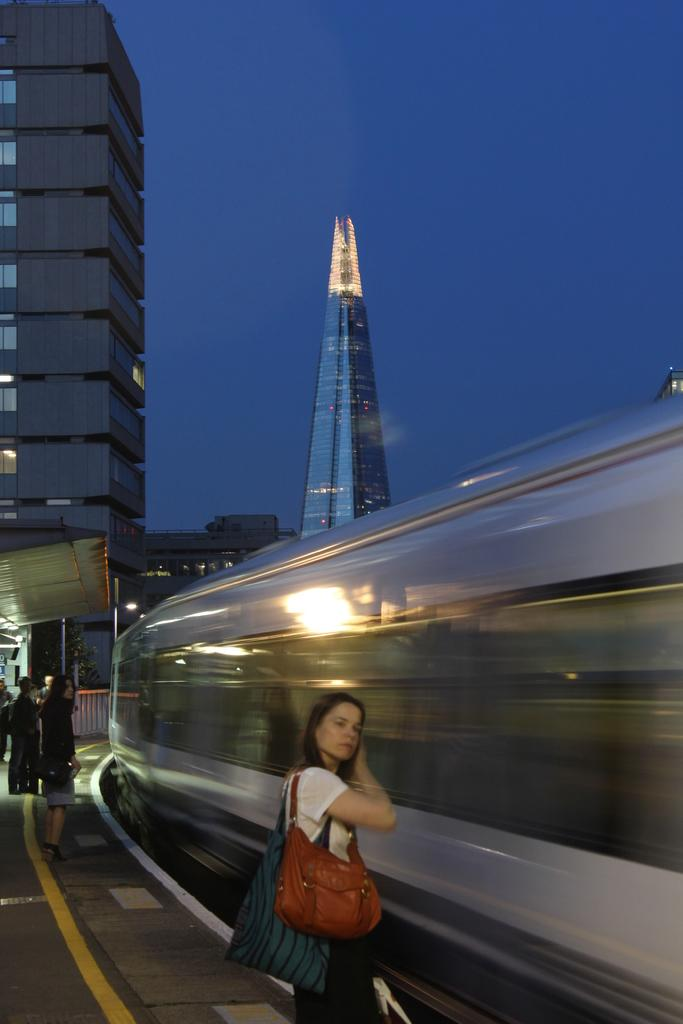What is the main subject of the image? The main subject of the image is a train on the track. What else can be seen in the image besides the train? There is a group of people standing on a platform, buildings, a light, and the sky are visible in the image. Where are the people located in relation to the train? The people are standing on a platform, which is separate from the train track. What is the condition of the sky in the image? The sky is visible in the image, but no specific weather conditions are mentioned. What type of fork can be seen in the image? There is no fork present in the image. What type of celery is being used as a decoration in the image? There is no celery present in the image. 